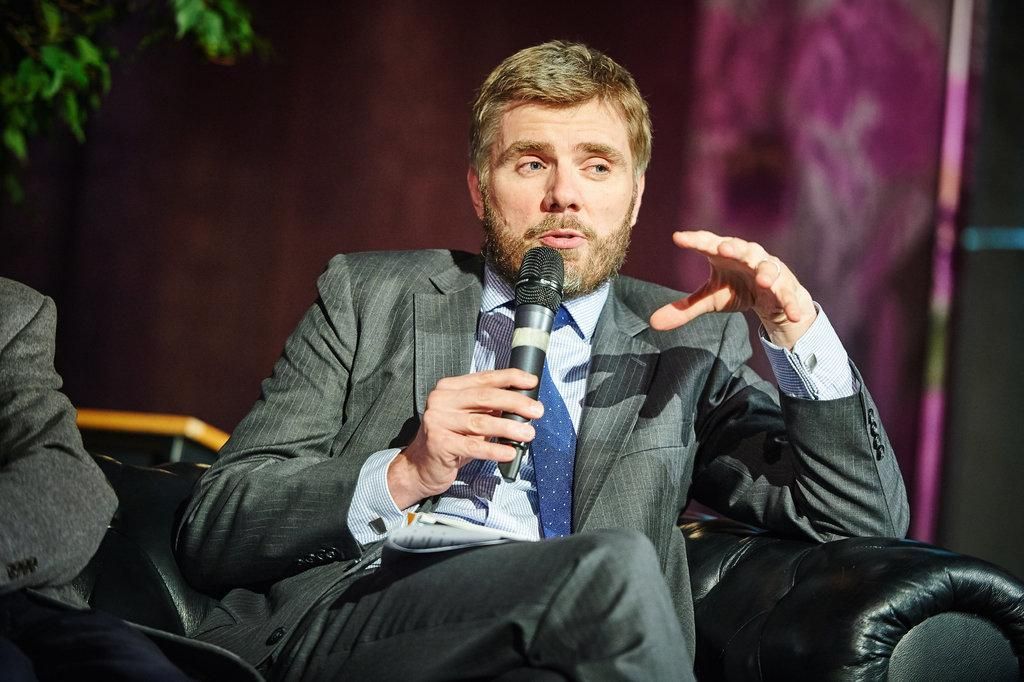What is the main subject of the image? The main subject of the image is a man. What is the man doing in the image? The man is sitting on a chair and holding a microphone. What can be seen in the background of the image? There is a wall in the background of the image. Can you see any ants carrying popcorn across the stream in the image? There is no reference to ants, popcorn, or a stream in the image, so it's not possible to answer that question. 